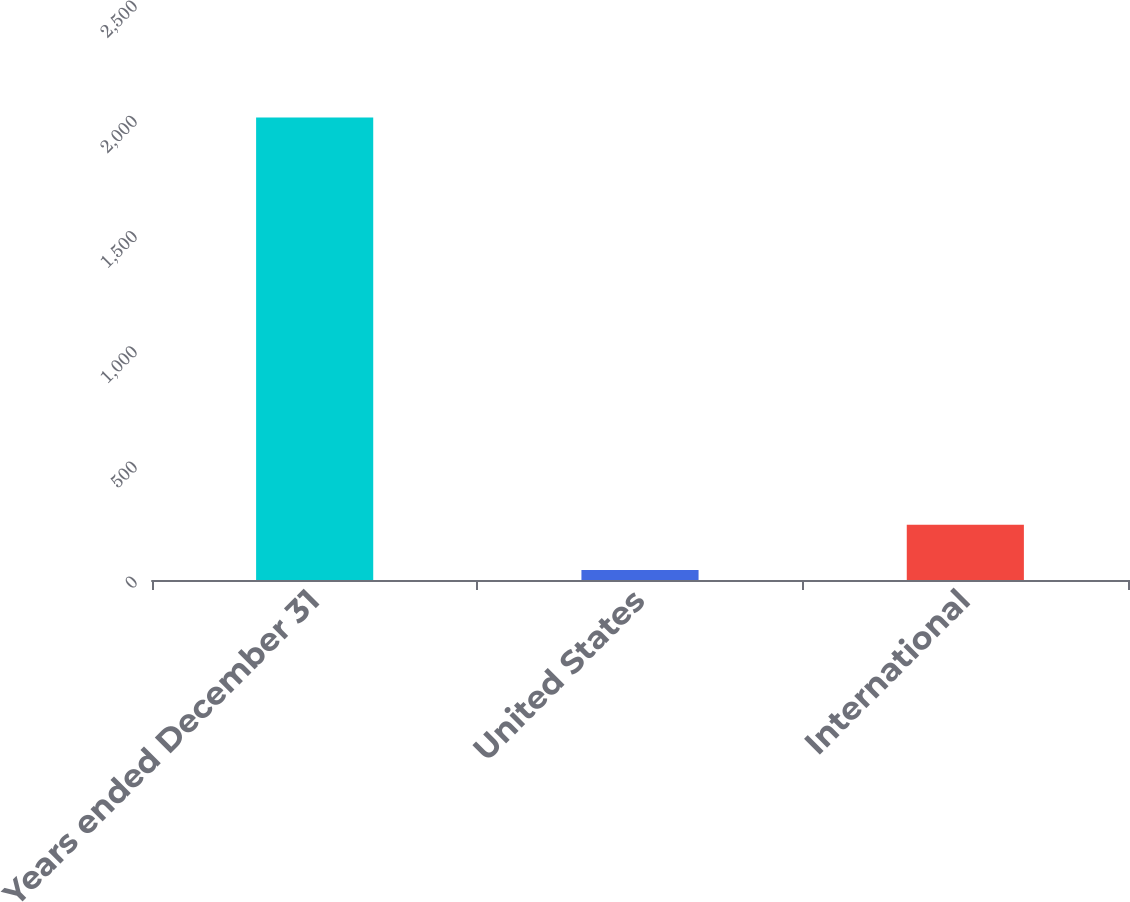<chart> <loc_0><loc_0><loc_500><loc_500><bar_chart><fcel>Years ended December 31<fcel>United States<fcel>International<nl><fcel>2007<fcel>43<fcel>239.4<nl></chart> 